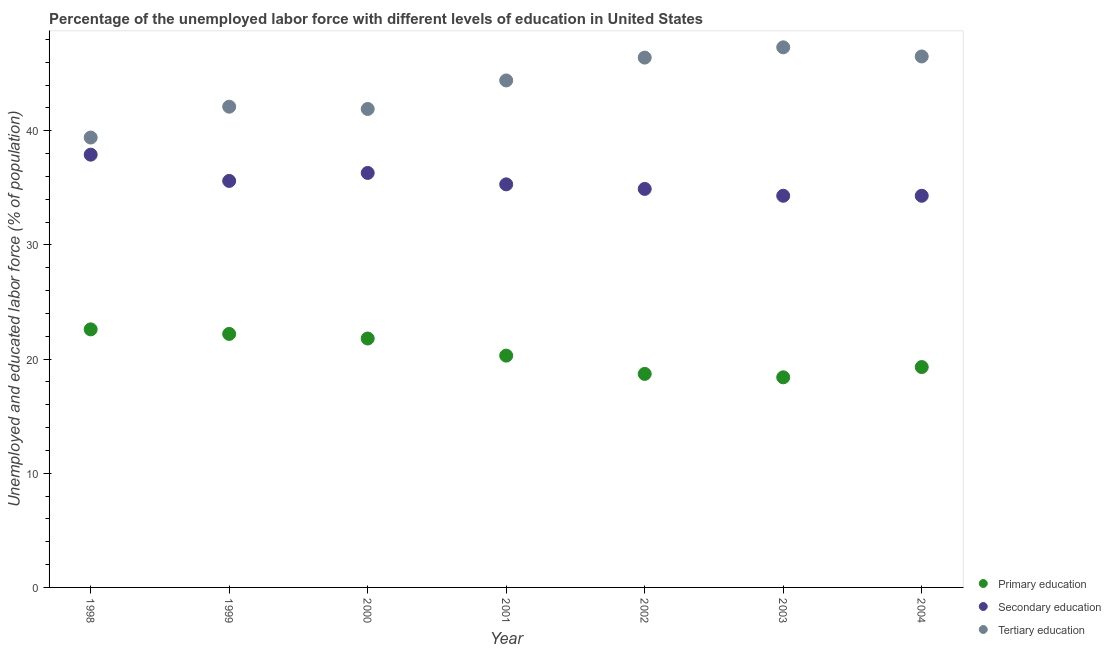What is the percentage of labor force who received primary education in 1999?
Keep it short and to the point. 22.2. Across all years, what is the maximum percentage of labor force who received secondary education?
Your answer should be very brief. 37.9. Across all years, what is the minimum percentage of labor force who received primary education?
Keep it short and to the point. 18.4. In which year was the percentage of labor force who received primary education maximum?
Ensure brevity in your answer.  1998. In which year was the percentage of labor force who received secondary education minimum?
Provide a short and direct response. 2003. What is the total percentage of labor force who received primary education in the graph?
Provide a short and direct response. 143.3. What is the difference between the percentage of labor force who received secondary education in 1998 and that in 2004?
Provide a short and direct response. 3.6. What is the difference between the percentage of labor force who received tertiary education in 2003 and the percentage of labor force who received primary education in 1999?
Make the answer very short. 25.1. What is the average percentage of labor force who received tertiary education per year?
Your answer should be compact. 44. In the year 2004, what is the difference between the percentage of labor force who received tertiary education and percentage of labor force who received secondary education?
Your answer should be compact. 12.2. In how many years, is the percentage of labor force who received primary education greater than 32 %?
Your response must be concise. 0. What is the ratio of the percentage of labor force who received secondary education in 1999 to that in 2003?
Your response must be concise. 1.04. Is the percentage of labor force who received tertiary education in 2001 less than that in 2004?
Your answer should be compact. Yes. What is the difference between the highest and the second highest percentage of labor force who received tertiary education?
Give a very brief answer. 0.8. What is the difference between the highest and the lowest percentage of labor force who received primary education?
Your answer should be very brief. 4.2. Is the sum of the percentage of labor force who received primary education in 1999 and 2002 greater than the maximum percentage of labor force who received tertiary education across all years?
Your answer should be very brief. No. Is it the case that in every year, the sum of the percentage of labor force who received primary education and percentage of labor force who received secondary education is greater than the percentage of labor force who received tertiary education?
Your answer should be very brief. Yes. Does the percentage of labor force who received secondary education monotonically increase over the years?
Provide a short and direct response. No. Is the percentage of labor force who received secondary education strictly greater than the percentage of labor force who received primary education over the years?
Offer a terse response. Yes. How many dotlines are there?
Give a very brief answer. 3. Are the values on the major ticks of Y-axis written in scientific E-notation?
Provide a succinct answer. No. Does the graph contain grids?
Give a very brief answer. No. Where does the legend appear in the graph?
Ensure brevity in your answer.  Bottom right. How are the legend labels stacked?
Keep it short and to the point. Vertical. What is the title of the graph?
Keep it short and to the point. Percentage of the unemployed labor force with different levels of education in United States. Does "Ages 20-60" appear as one of the legend labels in the graph?
Give a very brief answer. No. What is the label or title of the Y-axis?
Make the answer very short. Unemployed and educated labor force (% of population). What is the Unemployed and educated labor force (% of population) in Primary education in 1998?
Your response must be concise. 22.6. What is the Unemployed and educated labor force (% of population) in Secondary education in 1998?
Offer a terse response. 37.9. What is the Unemployed and educated labor force (% of population) in Tertiary education in 1998?
Provide a short and direct response. 39.4. What is the Unemployed and educated labor force (% of population) of Primary education in 1999?
Give a very brief answer. 22.2. What is the Unemployed and educated labor force (% of population) of Secondary education in 1999?
Offer a terse response. 35.6. What is the Unemployed and educated labor force (% of population) of Tertiary education in 1999?
Your answer should be compact. 42.1. What is the Unemployed and educated labor force (% of population) of Primary education in 2000?
Provide a short and direct response. 21.8. What is the Unemployed and educated labor force (% of population) of Secondary education in 2000?
Provide a short and direct response. 36.3. What is the Unemployed and educated labor force (% of population) in Tertiary education in 2000?
Keep it short and to the point. 41.9. What is the Unemployed and educated labor force (% of population) of Primary education in 2001?
Ensure brevity in your answer.  20.3. What is the Unemployed and educated labor force (% of population) in Secondary education in 2001?
Your answer should be compact. 35.3. What is the Unemployed and educated labor force (% of population) in Tertiary education in 2001?
Offer a very short reply. 44.4. What is the Unemployed and educated labor force (% of population) in Primary education in 2002?
Ensure brevity in your answer.  18.7. What is the Unemployed and educated labor force (% of population) in Secondary education in 2002?
Offer a terse response. 34.9. What is the Unemployed and educated labor force (% of population) in Tertiary education in 2002?
Offer a very short reply. 46.4. What is the Unemployed and educated labor force (% of population) of Primary education in 2003?
Offer a terse response. 18.4. What is the Unemployed and educated labor force (% of population) in Secondary education in 2003?
Ensure brevity in your answer.  34.3. What is the Unemployed and educated labor force (% of population) in Tertiary education in 2003?
Keep it short and to the point. 47.3. What is the Unemployed and educated labor force (% of population) of Primary education in 2004?
Offer a very short reply. 19.3. What is the Unemployed and educated labor force (% of population) of Secondary education in 2004?
Offer a terse response. 34.3. What is the Unemployed and educated labor force (% of population) of Tertiary education in 2004?
Your response must be concise. 46.5. Across all years, what is the maximum Unemployed and educated labor force (% of population) in Primary education?
Offer a terse response. 22.6. Across all years, what is the maximum Unemployed and educated labor force (% of population) in Secondary education?
Make the answer very short. 37.9. Across all years, what is the maximum Unemployed and educated labor force (% of population) of Tertiary education?
Give a very brief answer. 47.3. Across all years, what is the minimum Unemployed and educated labor force (% of population) in Primary education?
Your answer should be very brief. 18.4. Across all years, what is the minimum Unemployed and educated labor force (% of population) in Secondary education?
Offer a very short reply. 34.3. Across all years, what is the minimum Unemployed and educated labor force (% of population) in Tertiary education?
Provide a short and direct response. 39.4. What is the total Unemployed and educated labor force (% of population) in Primary education in the graph?
Provide a succinct answer. 143.3. What is the total Unemployed and educated labor force (% of population) in Secondary education in the graph?
Keep it short and to the point. 248.6. What is the total Unemployed and educated labor force (% of population) in Tertiary education in the graph?
Keep it short and to the point. 308. What is the difference between the Unemployed and educated labor force (% of population) in Primary education in 1998 and that in 1999?
Keep it short and to the point. 0.4. What is the difference between the Unemployed and educated labor force (% of population) of Secondary education in 1998 and that in 1999?
Give a very brief answer. 2.3. What is the difference between the Unemployed and educated labor force (% of population) of Primary education in 1998 and that in 2002?
Offer a very short reply. 3.9. What is the difference between the Unemployed and educated labor force (% of population) of Tertiary education in 1998 and that in 2002?
Keep it short and to the point. -7. What is the difference between the Unemployed and educated labor force (% of population) in Primary education in 1998 and that in 2003?
Keep it short and to the point. 4.2. What is the difference between the Unemployed and educated labor force (% of population) of Secondary education in 1998 and that in 2003?
Give a very brief answer. 3.6. What is the difference between the Unemployed and educated labor force (% of population) in Secondary education in 1998 and that in 2004?
Keep it short and to the point. 3.6. What is the difference between the Unemployed and educated labor force (% of population) of Tertiary education in 1998 and that in 2004?
Your answer should be compact. -7.1. What is the difference between the Unemployed and educated labor force (% of population) in Tertiary education in 1999 and that in 2001?
Provide a short and direct response. -2.3. What is the difference between the Unemployed and educated labor force (% of population) of Primary education in 1999 and that in 2002?
Offer a terse response. 3.5. What is the difference between the Unemployed and educated labor force (% of population) of Secondary education in 1999 and that in 2002?
Offer a terse response. 0.7. What is the difference between the Unemployed and educated labor force (% of population) of Tertiary education in 1999 and that in 2002?
Give a very brief answer. -4.3. What is the difference between the Unemployed and educated labor force (% of population) of Secondary education in 1999 and that in 2004?
Offer a terse response. 1.3. What is the difference between the Unemployed and educated labor force (% of population) of Tertiary education in 1999 and that in 2004?
Offer a very short reply. -4.4. What is the difference between the Unemployed and educated labor force (% of population) in Primary education in 2000 and that in 2002?
Keep it short and to the point. 3.1. What is the difference between the Unemployed and educated labor force (% of population) of Tertiary education in 2000 and that in 2002?
Make the answer very short. -4.5. What is the difference between the Unemployed and educated labor force (% of population) in Primary education in 2000 and that in 2003?
Offer a very short reply. 3.4. What is the difference between the Unemployed and educated labor force (% of population) in Tertiary education in 2000 and that in 2003?
Keep it short and to the point. -5.4. What is the difference between the Unemployed and educated labor force (% of population) in Primary education in 2001 and that in 2002?
Provide a succinct answer. 1.6. What is the difference between the Unemployed and educated labor force (% of population) in Secondary education in 2001 and that in 2002?
Your response must be concise. 0.4. What is the difference between the Unemployed and educated labor force (% of population) of Primary education in 2001 and that in 2003?
Keep it short and to the point. 1.9. What is the difference between the Unemployed and educated labor force (% of population) in Secondary education in 2001 and that in 2003?
Offer a very short reply. 1. What is the difference between the Unemployed and educated labor force (% of population) of Primary education in 2001 and that in 2004?
Provide a succinct answer. 1. What is the difference between the Unemployed and educated labor force (% of population) in Secondary education in 2001 and that in 2004?
Your answer should be compact. 1. What is the difference between the Unemployed and educated labor force (% of population) of Tertiary education in 2001 and that in 2004?
Provide a succinct answer. -2.1. What is the difference between the Unemployed and educated labor force (% of population) in Secondary education in 2002 and that in 2003?
Keep it short and to the point. 0.6. What is the difference between the Unemployed and educated labor force (% of population) in Tertiary education in 2002 and that in 2003?
Make the answer very short. -0.9. What is the difference between the Unemployed and educated labor force (% of population) of Tertiary education in 2002 and that in 2004?
Offer a very short reply. -0.1. What is the difference between the Unemployed and educated labor force (% of population) of Primary education in 2003 and that in 2004?
Ensure brevity in your answer.  -0.9. What is the difference between the Unemployed and educated labor force (% of population) of Tertiary education in 2003 and that in 2004?
Offer a terse response. 0.8. What is the difference between the Unemployed and educated labor force (% of population) of Primary education in 1998 and the Unemployed and educated labor force (% of population) of Tertiary education in 1999?
Provide a succinct answer. -19.5. What is the difference between the Unemployed and educated labor force (% of population) in Secondary education in 1998 and the Unemployed and educated labor force (% of population) in Tertiary education in 1999?
Your response must be concise. -4.2. What is the difference between the Unemployed and educated labor force (% of population) in Primary education in 1998 and the Unemployed and educated labor force (% of population) in Secondary education in 2000?
Your answer should be compact. -13.7. What is the difference between the Unemployed and educated labor force (% of population) of Primary education in 1998 and the Unemployed and educated labor force (% of population) of Tertiary education in 2000?
Keep it short and to the point. -19.3. What is the difference between the Unemployed and educated labor force (% of population) in Primary education in 1998 and the Unemployed and educated labor force (% of population) in Secondary education in 2001?
Offer a very short reply. -12.7. What is the difference between the Unemployed and educated labor force (% of population) in Primary education in 1998 and the Unemployed and educated labor force (% of population) in Tertiary education in 2001?
Your answer should be very brief. -21.8. What is the difference between the Unemployed and educated labor force (% of population) of Primary education in 1998 and the Unemployed and educated labor force (% of population) of Secondary education in 2002?
Make the answer very short. -12.3. What is the difference between the Unemployed and educated labor force (% of population) in Primary education in 1998 and the Unemployed and educated labor force (% of population) in Tertiary education in 2002?
Keep it short and to the point. -23.8. What is the difference between the Unemployed and educated labor force (% of population) of Secondary education in 1998 and the Unemployed and educated labor force (% of population) of Tertiary education in 2002?
Make the answer very short. -8.5. What is the difference between the Unemployed and educated labor force (% of population) of Primary education in 1998 and the Unemployed and educated labor force (% of population) of Secondary education in 2003?
Make the answer very short. -11.7. What is the difference between the Unemployed and educated labor force (% of population) in Primary education in 1998 and the Unemployed and educated labor force (% of population) in Tertiary education in 2003?
Provide a succinct answer. -24.7. What is the difference between the Unemployed and educated labor force (% of population) of Primary education in 1998 and the Unemployed and educated labor force (% of population) of Tertiary education in 2004?
Give a very brief answer. -23.9. What is the difference between the Unemployed and educated labor force (% of population) in Secondary education in 1998 and the Unemployed and educated labor force (% of population) in Tertiary education in 2004?
Provide a succinct answer. -8.6. What is the difference between the Unemployed and educated labor force (% of population) in Primary education in 1999 and the Unemployed and educated labor force (% of population) in Secondary education in 2000?
Keep it short and to the point. -14.1. What is the difference between the Unemployed and educated labor force (% of population) of Primary education in 1999 and the Unemployed and educated labor force (% of population) of Tertiary education in 2000?
Provide a short and direct response. -19.7. What is the difference between the Unemployed and educated labor force (% of population) of Secondary education in 1999 and the Unemployed and educated labor force (% of population) of Tertiary education in 2000?
Your answer should be compact. -6.3. What is the difference between the Unemployed and educated labor force (% of population) of Primary education in 1999 and the Unemployed and educated labor force (% of population) of Secondary education in 2001?
Provide a succinct answer. -13.1. What is the difference between the Unemployed and educated labor force (% of population) of Primary education in 1999 and the Unemployed and educated labor force (% of population) of Tertiary education in 2001?
Offer a terse response. -22.2. What is the difference between the Unemployed and educated labor force (% of population) in Secondary education in 1999 and the Unemployed and educated labor force (% of population) in Tertiary education in 2001?
Ensure brevity in your answer.  -8.8. What is the difference between the Unemployed and educated labor force (% of population) in Primary education in 1999 and the Unemployed and educated labor force (% of population) in Secondary education in 2002?
Keep it short and to the point. -12.7. What is the difference between the Unemployed and educated labor force (% of population) of Primary education in 1999 and the Unemployed and educated labor force (% of population) of Tertiary education in 2002?
Your answer should be compact. -24.2. What is the difference between the Unemployed and educated labor force (% of population) of Primary education in 1999 and the Unemployed and educated labor force (% of population) of Tertiary education in 2003?
Provide a short and direct response. -25.1. What is the difference between the Unemployed and educated labor force (% of population) in Primary education in 1999 and the Unemployed and educated labor force (% of population) in Secondary education in 2004?
Your answer should be very brief. -12.1. What is the difference between the Unemployed and educated labor force (% of population) of Primary education in 1999 and the Unemployed and educated labor force (% of population) of Tertiary education in 2004?
Your answer should be compact. -24.3. What is the difference between the Unemployed and educated labor force (% of population) in Primary education in 2000 and the Unemployed and educated labor force (% of population) in Secondary education in 2001?
Keep it short and to the point. -13.5. What is the difference between the Unemployed and educated labor force (% of population) of Primary education in 2000 and the Unemployed and educated labor force (% of population) of Tertiary education in 2001?
Provide a succinct answer. -22.6. What is the difference between the Unemployed and educated labor force (% of population) in Primary education in 2000 and the Unemployed and educated labor force (% of population) in Secondary education in 2002?
Provide a succinct answer. -13.1. What is the difference between the Unemployed and educated labor force (% of population) of Primary education in 2000 and the Unemployed and educated labor force (% of population) of Tertiary education in 2002?
Provide a succinct answer. -24.6. What is the difference between the Unemployed and educated labor force (% of population) in Primary education in 2000 and the Unemployed and educated labor force (% of population) in Secondary education in 2003?
Keep it short and to the point. -12.5. What is the difference between the Unemployed and educated labor force (% of population) of Primary education in 2000 and the Unemployed and educated labor force (% of population) of Tertiary education in 2003?
Make the answer very short. -25.5. What is the difference between the Unemployed and educated labor force (% of population) of Secondary education in 2000 and the Unemployed and educated labor force (% of population) of Tertiary education in 2003?
Your answer should be compact. -11. What is the difference between the Unemployed and educated labor force (% of population) in Primary education in 2000 and the Unemployed and educated labor force (% of population) in Tertiary education in 2004?
Provide a short and direct response. -24.7. What is the difference between the Unemployed and educated labor force (% of population) of Primary education in 2001 and the Unemployed and educated labor force (% of population) of Secondary education in 2002?
Give a very brief answer. -14.6. What is the difference between the Unemployed and educated labor force (% of population) in Primary education in 2001 and the Unemployed and educated labor force (% of population) in Tertiary education in 2002?
Keep it short and to the point. -26.1. What is the difference between the Unemployed and educated labor force (% of population) of Primary education in 2001 and the Unemployed and educated labor force (% of population) of Secondary education in 2003?
Your answer should be compact. -14. What is the difference between the Unemployed and educated labor force (% of population) of Primary education in 2001 and the Unemployed and educated labor force (% of population) of Secondary education in 2004?
Your response must be concise. -14. What is the difference between the Unemployed and educated labor force (% of population) of Primary education in 2001 and the Unemployed and educated labor force (% of population) of Tertiary education in 2004?
Your answer should be very brief. -26.2. What is the difference between the Unemployed and educated labor force (% of population) in Secondary education in 2001 and the Unemployed and educated labor force (% of population) in Tertiary education in 2004?
Your response must be concise. -11.2. What is the difference between the Unemployed and educated labor force (% of population) in Primary education in 2002 and the Unemployed and educated labor force (% of population) in Secondary education in 2003?
Keep it short and to the point. -15.6. What is the difference between the Unemployed and educated labor force (% of population) of Primary education in 2002 and the Unemployed and educated labor force (% of population) of Tertiary education in 2003?
Make the answer very short. -28.6. What is the difference between the Unemployed and educated labor force (% of population) in Primary education in 2002 and the Unemployed and educated labor force (% of population) in Secondary education in 2004?
Keep it short and to the point. -15.6. What is the difference between the Unemployed and educated labor force (% of population) of Primary education in 2002 and the Unemployed and educated labor force (% of population) of Tertiary education in 2004?
Provide a short and direct response. -27.8. What is the difference between the Unemployed and educated labor force (% of population) of Secondary education in 2002 and the Unemployed and educated labor force (% of population) of Tertiary education in 2004?
Provide a succinct answer. -11.6. What is the difference between the Unemployed and educated labor force (% of population) in Primary education in 2003 and the Unemployed and educated labor force (% of population) in Secondary education in 2004?
Ensure brevity in your answer.  -15.9. What is the difference between the Unemployed and educated labor force (% of population) in Primary education in 2003 and the Unemployed and educated labor force (% of population) in Tertiary education in 2004?
Your answer should be very brief. -28.1. What is the average Unemployed and educated labor force (% of population) in Primary education per year?
Your answer should be compact. 20.47. What is the average Unemployed and educated labor force (% of population) of Secondary education per year?
Make the answer very short. 35.51. What is the average Unemployed and educated labor force (% of population) of Tertiary education per year?
Your answer should be very brief. 44. In the year 1998, what is the difference between the Unemployed and educated labor force (% of population) in Primary education and Unemployed and educated labor force (% of population) in Secondary education?
Make the answer very short. -15.3. In the year 1998, what is the difference between the Unemployed and educated labor force (% of population) of Primary education and Unemployed and educated labor force (% of population) of Tertiary education?
Keep it short and to the point. -16.8. In the year 1999, what is the difference between the Unemployed and educated labor force (% of population) of Primary education and Unemployed and educated labor force (% of population) of Tertiary education?
Your answer should be compact. -19.9. In the year 1999, what is the difference between the Unemployed and educated labor force (% of population) of Secondary education and Unemployed and educated labor force (% of population) of Tertiary education?
Your response must be concise. -6.5. In the year 2000, what is the difference between the Unemployed and educated labor force (% of population) of Primary education and Unemployed and educated labor force (% of population) of Secondary education?
Provide a short and direct response. -14.5. In the year 2000, what is the difference between the Unemployed and educated labor force (% of population) of Primary education and Unemployed and educated labor force (% of population) of Tertiary education?
Your answer should be very brief. -20.1. In the year 2000, what is the difference between the Unemployed and educated labor force (% of population) in Secondary education and Unemployed and educated labor force (% of population) in Tertiary education?
Provide a short and direct response. -5.6. In the year 2001, what is the difference between the Unemployed and educated labor force (% of population) in Primary education and Unemployed and educated labor force (% of population) in Tertiary education?
Ensure brevity in your answer.  -24.1. In the year 2002, what is the difference between the Unemployed and educated labor force (% of population) of Primary education and Unemployed and educated labor force (% of population) of Secondary education?
Your answer should be very brief. -16.2. In the year 2002, what is the difference between the Unemployed and educated labor force (% of population) of Primary education and Unemployed and educated labor force (% of population) of Tertiary education?
Offer a very short reply. -27.7. In the year 2003, what is the difference between the Unemployed and educated labor force (% of population) of Primary education and Unemployed and educated labor force (% of population) of Secondary education?
Your answer should be very brief. -15.9. In the year 2003, what is the difference between the Unemployed and educated labor force (% of population) of Primary education and Unemployed and educated labor force (% of population) of Tertiary education?
Offer a very short reply. -28.9. In the year 2003, what is the difference between the Unemployed and educated labor force (% of population) of Secondary education and Unemployed and educated labor force (% of population) of Tertiary education?
Provide a short and direct response. -13. In the year 2004, what is the difference between the Unemployed and educated labor force (% of population) in Primary education and Unemployed and educated labor force (% of population) in Secondary education?
Your response must be concise. -15. In the year 2004, what is the difference between the Unemployed and educated labor force (% of population) of Primary education and Unemployed and educated labor force (% of population) of Tertiary education?
Your response must be concise. -27.2. In the year 2004, what is the difference between the Unemployed and educated labor force (% of population) in Secondary education and Unemployed and educated labor force (% of population) in Tertiary education?
Give a very brief answer. -12.2. What is the ratio of the Unemployed and educated labor force (% of population) in Primary education in 1998 to that in 1999?
Keep it short and to the point. 1.02. What is the ratio of the Unemployed and educated labor force (% of population) of Secondary education in 1998 to that in 1999?
Offer a terse response. 1.06. What is the ratio of the Unemployed and educated labor force (% of population) of Tertiary education in 1998 to that in 1999?
Give a very brief answer. 0.94. What is the ratio of the Unemployed and educated labor force (% of population) in Primary education in 1998 to that in 2000?
Keep it short and to the point. 1.04. What is the ratio of the Unemployed and educated labor force (% of population) in Secondary education in 1998 to that in 2000?
Ensure brevity in your answer.  1.04. What is the ratio of the Unemployed and educated labor force (% of population) in Tertiary education in 1998 to that in 2000?
Your response must be concise. 0.94. What is the ratio of the Unemployed and educated labor force (% of population) in Primary education in 1998 to that in 2001?
Give a very brief answer. 1.11. What is the ratio of the Unemployed and educated labor force (% of population) in Secondary education in 1998 to that in 2001?
Your answer should be compact. 1.07. What is the ratio of the Unemployed and educated labor force (% of population) of Tertiary education in 1998 to that in 2001?
Give a very brief answer. 0.89. What is the ratio of the Unemployed and educated labor force (% of population) in Primary education in 1998 to that in 2002?
Provide a short and direct response. 1.21. What is the ratio of the Unemployed and educated labor force (% of population) in Secondary education in 1998 to that in 2002?
Provide a short and direct response. 1.09. What is the ratio of the Unemployed and educated labor force (% of population) of Tertiary education in 1998 to that in 2002?
Your response must be concise. 0.85. What is the ratio of the Unemployed and educated labor force (% of population) of Primary education in 1998 to that in 2003?
Your answer should be compact. 1.23. What is the ratio of the Unemployed and educated labor force (% of population) in Secondary education in 1998 to that in 2003?
Provide a succinct answer. 1.1. What is the ratio of the Unemployed and educated labor force (% of population) in Tertiary education in 1998 to that in 2003?
Ensure brevity in your answer.  0.83. What is the ratio of the Unemployed and educated labor force (% of population) in Primary education in 1998 to that in 2004?
Keep it short and to the point. 1.17. What is the ratio of the Unemployed and educated labor force (% of population) of Secondary education in 1998 to that in 2004?
Provide a short and direct response. 1.1. What is the ratio of the Unemployed and educated labor force (% of population) in Tertiary education in 1998 to that in 2004?
Offer a terse response. 0.85. What is the ratio of the Unemployed and educated labor force (% of population) of Primary education in 1999 to that in 2000?
Give a very brief answer. 1.02. What is the ratio of the Unemployed and educated labor force (% of population) of Secondary education in 1999 to that in 2000?
Offer a very short reply. 0.98. What is the ratio of the Unemployed and educated labor force (% of population) in Primary education in 1999 to that in 2001?
Your response must be concise. 1.09. What is the ratio of the Unemployed and educated labor force (% of population) in Secondary education in 1999 to that in 2001?
Your answer should be compact. 1.01. What is the ratio of the Unemployed and educated labor force (% of population) in Tertiary education in 1999 to that in 2001?
Make the answer very short. 0.95. What is the ratio of the Unemployed and educated labor force (% of population) in Primary education in 1999 to that in 2002?
Offer a terse response. 1.19. What is the ratio of the Unemployed and educated labor force (% of population) of Secondary education in 1999 to that in 2002?
Your response must be concise. 1.02. What is the ratio of the Unemployed and educated labor force (% of population) in Tertiary education in 1999 to that in 2002?
Your answer should be very brief. 0.91. What is the ratio of the Unemployed and educated labor force (% of population) of Primary education in 1999 to that in 2003?
Your answer should be compact. 1.21. What is the ratio of the Unemployed and educated labor force (% of population) of Secondary education in 1999 to that in 2003?
Offer a terse response. 1.04. What is the ratio of the Unemployed and educated labor force (% of population) of Tertiary education in 1999 to that in 2003?
Offer a terse response. 0.89. What is the ratio of the Unemployed and educated labor force (% of population) of Primary education in 1999 to that in 2004?
Offer a terse response. 1.15. What is the ratio of the Unemployed and educated labor force (% of population) of Secondary education in 1999 to that in 2004?
Provide a succinct answer. 1.04. What is the ratio of the Unemployed and educated labor force (% of population) in Tertiary education in 1999 to that in 2004?
Provide a succinct answer. 0.91. What is the ratio of the Unemployed and educated labor force (% of population) of Primary education in 2000 to that in 2001?
Give a very brief answer. 1.07. What is the ratio of the Unemployed and educated labor force (% of population) in Secondary education in 2000 to that in 2001?
Make the answer very short. 1.03. What is the ratio of the Unemployed and educated labor force (% of population) of Tertiary education in 2000 to that in 2001?
Your response must be concise. 0.94. What is the ratio of the Unemployed and educated labor force (% of population) in Primary education in 2000 to that in 2002?
Provide a short and direct response. 1.17. What is the ratio of the Unemployed and educated labor force (% of population) of Secondary education in 2000 to that in 2002?
Ensure brevity in your answer.  1.04. What is the ratio of the Unemployed and educated labor force (% of population) of Tertiary education in 2000 to that in 2002?
Provide a succinct answer. 0.9. What is the ratio of the Unemployed and educated labor force (% of population) of Primary education in 2000 to that in 2003?
Your response must be concise. 1.18. What is the ratio of the Unemployed and educated labor force (% of population) in Secondary education in 2000 to that in 2003?
Your response must be concise. 1.06. What is the ratio of the Unemployed and educated labor force (% of population) of Tertiary education in 2000 to that in 2003?
Ensure brevity in your answer.  0.89. What is the ratio of the Unemployed and educated labor force (% of population) in Primary education in 2000 to that in 2004?
Provide a short and direct response. 1.13. What is the ratio of the Unemployed and educated labor force (% of population) of Secondary education in 2000 to that in 2004?
Give a very brief answer. 1.06. What is the ratio of the Unemployed and educated labor force (% of population) of Tertiary education in 2000 to that in 2004?
Provide a short and direct response. 0.9. What is the ratio of the Unemployed and educated labor force (% of population) in Primary education in 2001 to that in 2002?
Give a very brief answer. 1.09. What is the ratio of the Unemployed and educated labor force (% of population) of Secondary education in 2001 to that in 2002?
Ensure brevity in your answer.  1.01. What is the ratio of the Unemployed and educated labor force (% of population) of Tertiary education in 2001 to that in 2002?
Keep it short and to the point. 0.96. What is the ratio of the Unemployed and educated labor force (% of population) of Primary education in 2001 to that in 2003?
Keep it short and to the point. 1.1. What is the ratio of the Unemployed and educated labor force (% of population) of Secondary education in 2001 to that in 2003?
Provide a short and direct response. 1.03. What is the ratio of the Unemployed and educated labor force (% of population) in Tertiary education in 2001 to that in 2003?
Keep it short and to the point. 0.94. What is the ratio of the Unemployed and educated labor force (% of population) of Primary education in 2001 to that in 2004?
Your response must be concise. 1.05. What is the ratio of the Unemployed and educated labor force (% of population) in Secondary education in 2001 to that in 2004?
Ensure brevity in your answer.  1.03. What is the ratio of the Unemployed and educated labor force (% of population) of Tertiary education in 2001 to that in 2004?
Offer a very short reply. 0.95. What is the ratio of the Unemployed and educated labor force (% of population) in Primary education in 2002 to that in 2003?
Offer a terse response. 1.02. What is the ratio of the Unemployed and educated labor force (% of population) in Secondary education in 2002 to that in 2003?
Ensure brevity in your answer.  1.02. What is the ratio of the Unemployed and educated labor force (% of population) of Tertiary education in 2002 to that in 2003?
Offer a terse response. 0.98. What is the ratio of the Unemployed and educated labor force (% of population) of Primary education in 2002 to that in 2004?
Provide a succinct answer. 0.97. What is the ratio of the Unemployed and educated labor force (% of population) of Secondary education in 2002 to that in 2004?
Make the answer very short. 1.02. What is the ratio of the Unemployed and educated labor force (% of population) in Primary education in 2003 to that in 2004?
Give a very brief answer. 0.95. What is the ratio of the Unemployed and educated labor force (% of population) in Secondary education in 2003 to that in 2004?
Your response must be concise. 1. What is the ratio of the Unemployed and educated labor force (% of population) in Tertiary education in 2003 to that in 2004?
Give a very brief answer. 1.02. What is the difference between the highest and the second highest Unemployed and educated labor force (% of population) in Primary education?
Your answer should be compact. 0.4. What is the difference between the highest and the second highest Unemployed and educated labor force (% of population) in Secondary education?
Offer a very short reply. 1.6. What is the difference between the highest and the lowest Unemployed and educated labor force (% of population) in Primary education?
Give a very brief answer. 4.2. What is the difference between the highest and the lowest Unemployed and educated labor force (% of population) of Secondary education?
Ensure brevity in your answer.  3.6. What is the difference between the highest and the lowest Unemployed and educated labor force (% of population) of Tertiary education?
Give a very brief answer. 7.9. 